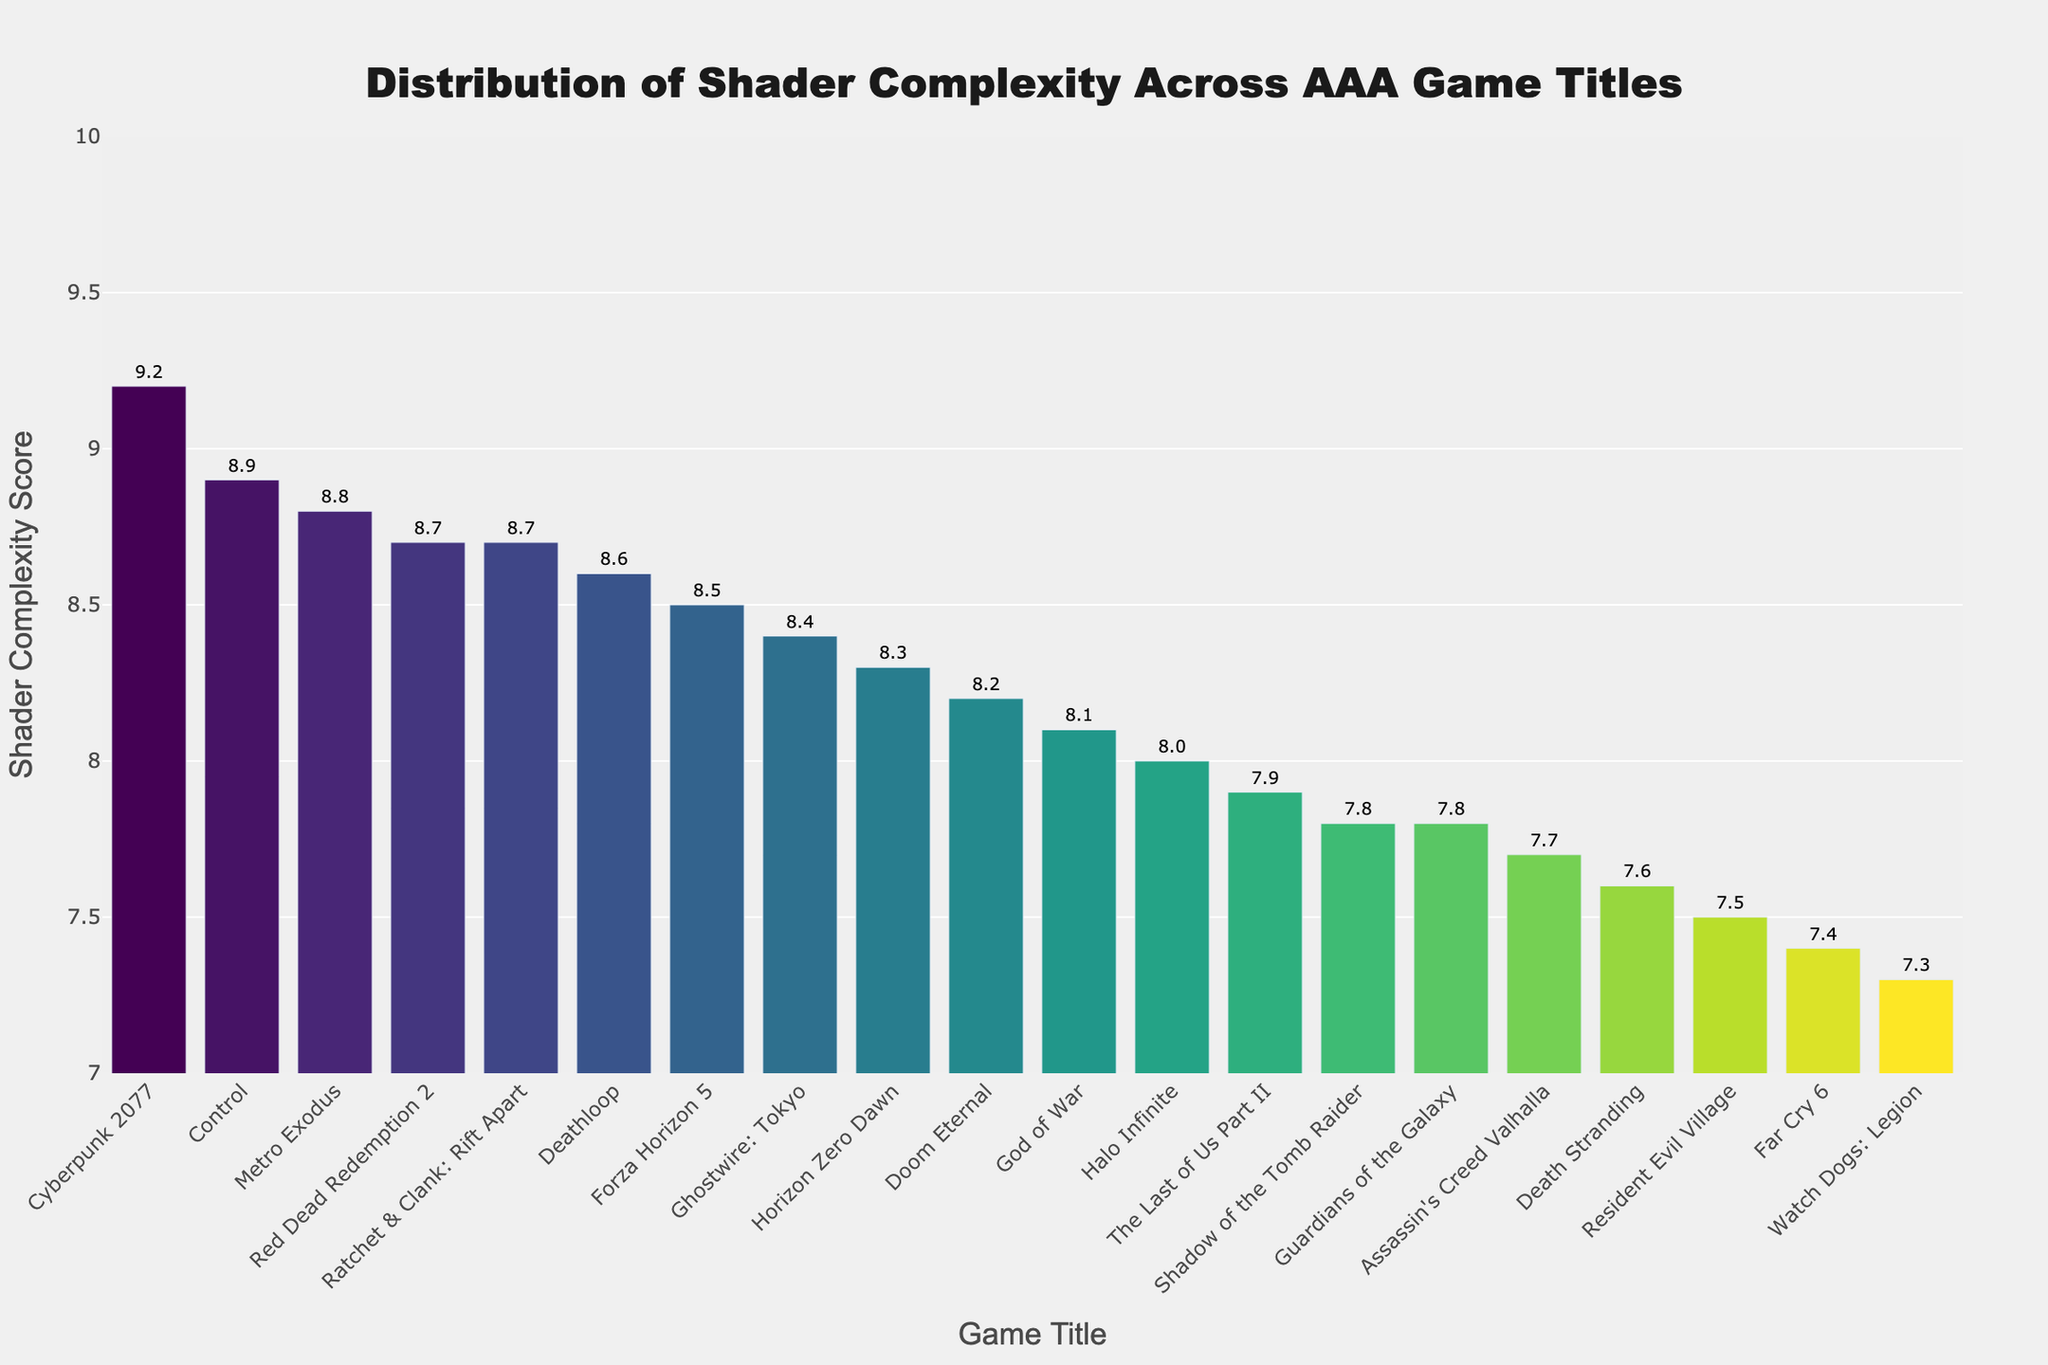What is the title of the plot? The title of the plot is usually placed at the top of the graph. In this case, it reads "Distribution of Shader Complexity Across AAA Game Titles".
Answer: Distribution of Shader Complexity Across AAA Game Titles What is the highest shader complexity score in the plot? To find the highest shader complexity score, we look at the tallest bar in the graph, which indicates Cyberpunk 2077 with a score of 9.2.
Answer: 9.2 Which game has the lowest shader complexity score? The game with the lowest shader complexity score is represented by the shortest bar, which in this case is Watch Dogs: Legion with a score of 7.3.
Answer: Watch Dogs: Legion How many games have a shader complexity score above 8.5? Count the number of bars that are higher than the 8.5 mark on the Y-axis. These games are Red Dead Redemption 2, Cyberpunk 2077, Control, Metro Exodus, and Ratchet & Clank: Rift Apart.
Answer: 5 What is the average shader complexity score of the games depicted? Sum all shader complexity scores and divide by the number of games. The sum of scores is 159.0 and there are 20 games, so the average is 159.0 / 20 = 7.95.
Answer: 7.95 Which game has a higher shader complexity score, Halo Infinite or Deathloop? Compare the height of the bars for both games. Halo Infinite has a shader complexity score of 8.0, while Deathloop has a score of 8.6.
Answer: Deathloop What's the difference in shader complexity score between Far Cry 6 and Ghostwire: Tokyo? Subtract the shader complexity score of Far Cry 6 from that of Ghostwire: Tokyo. Ghostwire: Tokyo has a score of 8.4 and Far Cry 6 has 7.4. Thus, the difference is 8.4 - 7.4 = 1.0.
Answer: 1.0 What is the median shader complexity score across the games? Organize the scores in ascending order and find the middle value. The sorted scores are [7.3, 7.4, 7.5, 7.6, 7.7, 7.8, 7.8, 7.9, 8.0, 8.1, 8.2, 8.3, 8.4, 8.5, 8.6, 8.7, 8.7, 8.8, 8.9, 9.2]. The median is the average of the 10th and 11th scores: (8.1 + 8.2) / 2 = 8.15.
Answer: 8.15 Are there more games with shader complexity scores above 8.0 or below 8.0? Count the number of games above and below 8.0. There are 14 games above 8.0 and 6 games below 8.0.
Answer: Above 8.0 